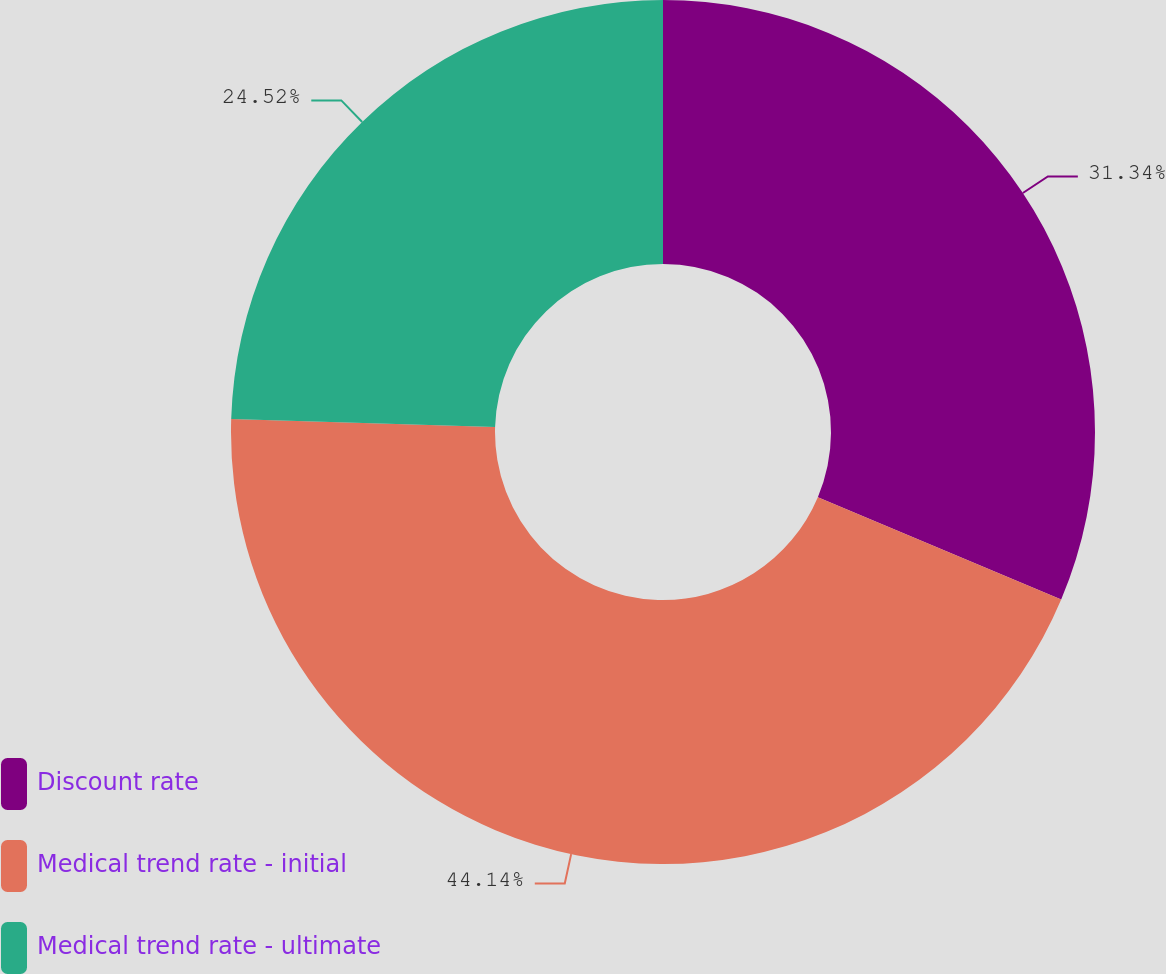Convert chart to OTSL. <chart><loc_0><loc_0><loc_500><loc_500><pie_chart><fcel>Discount rate<fcel>Medical trend rate - initial<fcel>Medical trend rate - ultimate<nl><fcel>31.34%<fcel>44.14%<fcel>24.52%<nl></chart> 